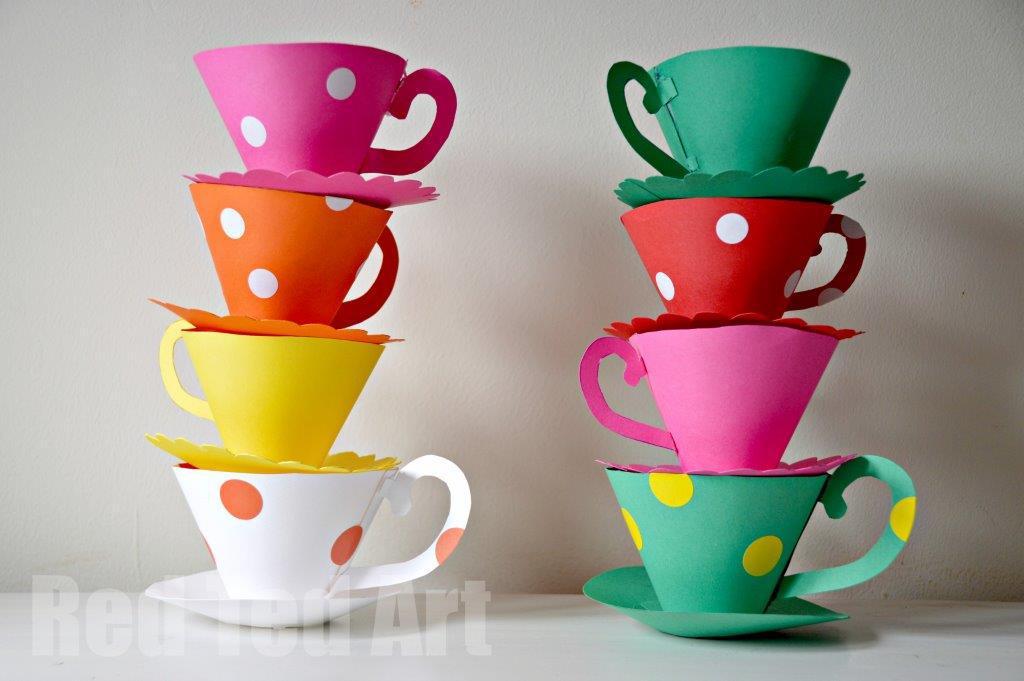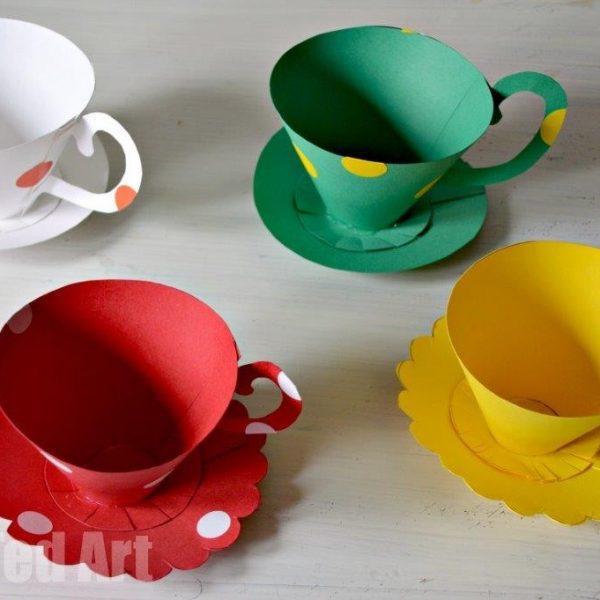The first image is the image on the left, the second image is the image on the right. For the images shown, is this caption "There are multiple paper cups on the left, but only one on the right." true? Answer yes or no. No. 